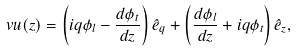<formula> <loc_0><loc_0><loc_500><loc_500>\ v u ( z ) = \left ( i q \phi _ { l } - \frac { d \phi _ { t } } { d z } \right ) \hat { e } _ { q } + \left ( \frac { d \phi _ { l } } { d z } + i q \phi _ { t } \right ) \hat { e } _ { z } ,</formula> 